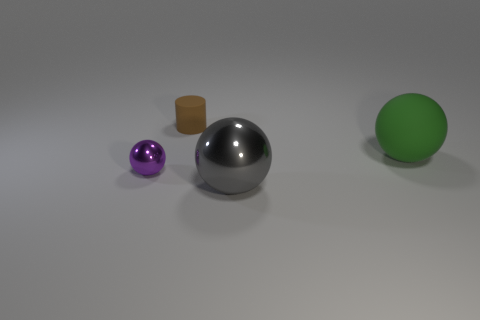What shape is the brown matte object that is the same size as the purple shiny ball? The brown matte object that matches the purple shiny ball in size is a cylinder. It stands upright with its circular base on the surface, differentiating it from the spherical shapes of the balls. 